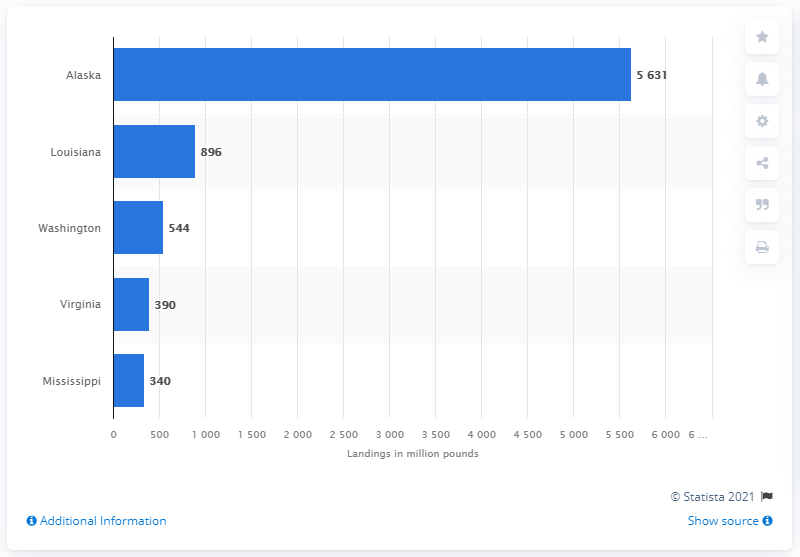List a handful of essential elements in this visual. In 2019, a total of 340 pounds of fish were landed in Mississippi. 